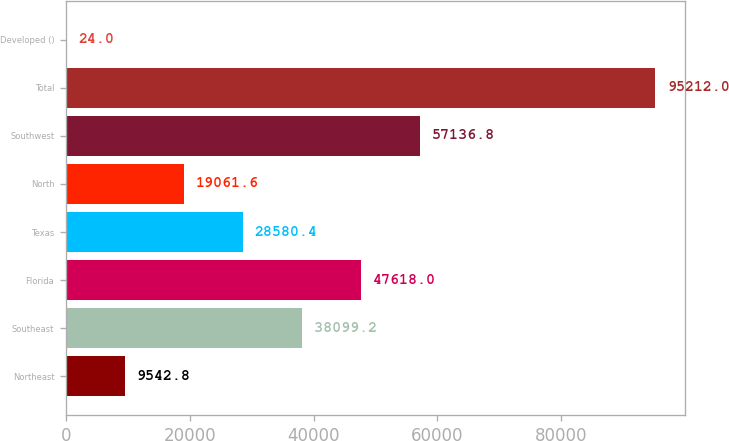Convert chart to OTSL. <chart><loc_0><loc_0><loc_500><loc_500><bar_chart><fcel>Northeast<fcel>Southeast<fcel>Florida<fcel>Texas<fcel>North<fcel>Southwest<fcel>Total<fcel>Developed ()<nl><fcel>9542.8<fcel>38099.2<fcel>47618<fcel>28580.4<fcel>19061.6<fcel>57136.8<fcel>95212<fcel>24<nl></chart> 